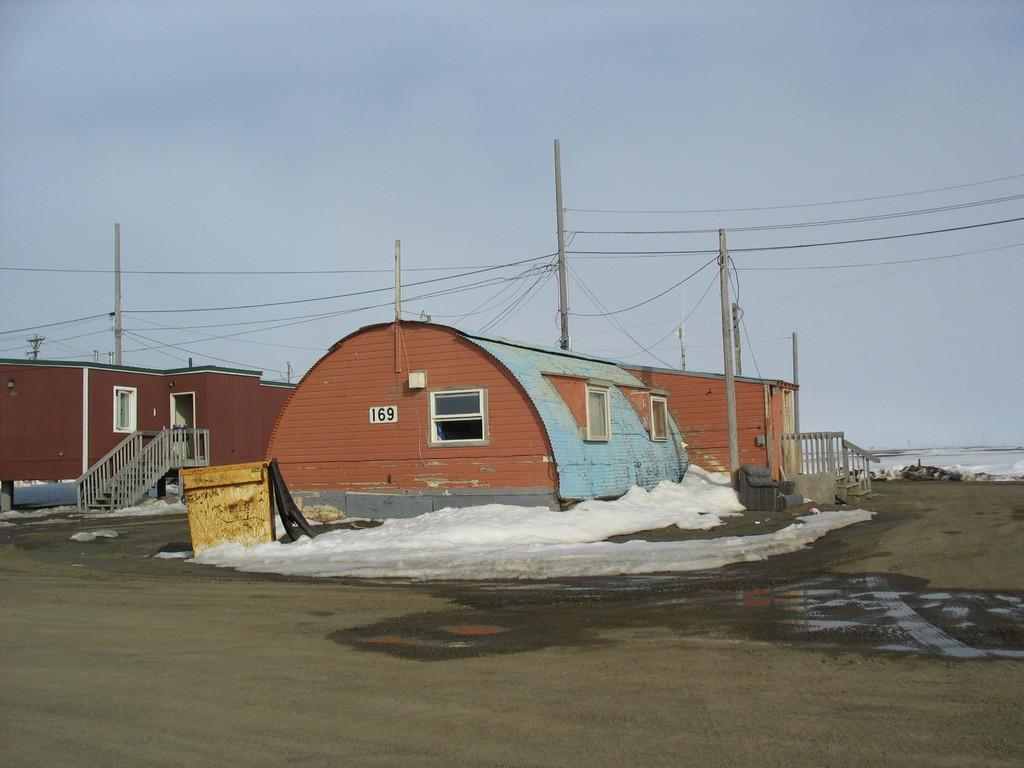Describe this image in one or two sentences. In this picture we can see ground, houses, poles, wires, windows, railings and objects. In the background of the image we can see the sky. 